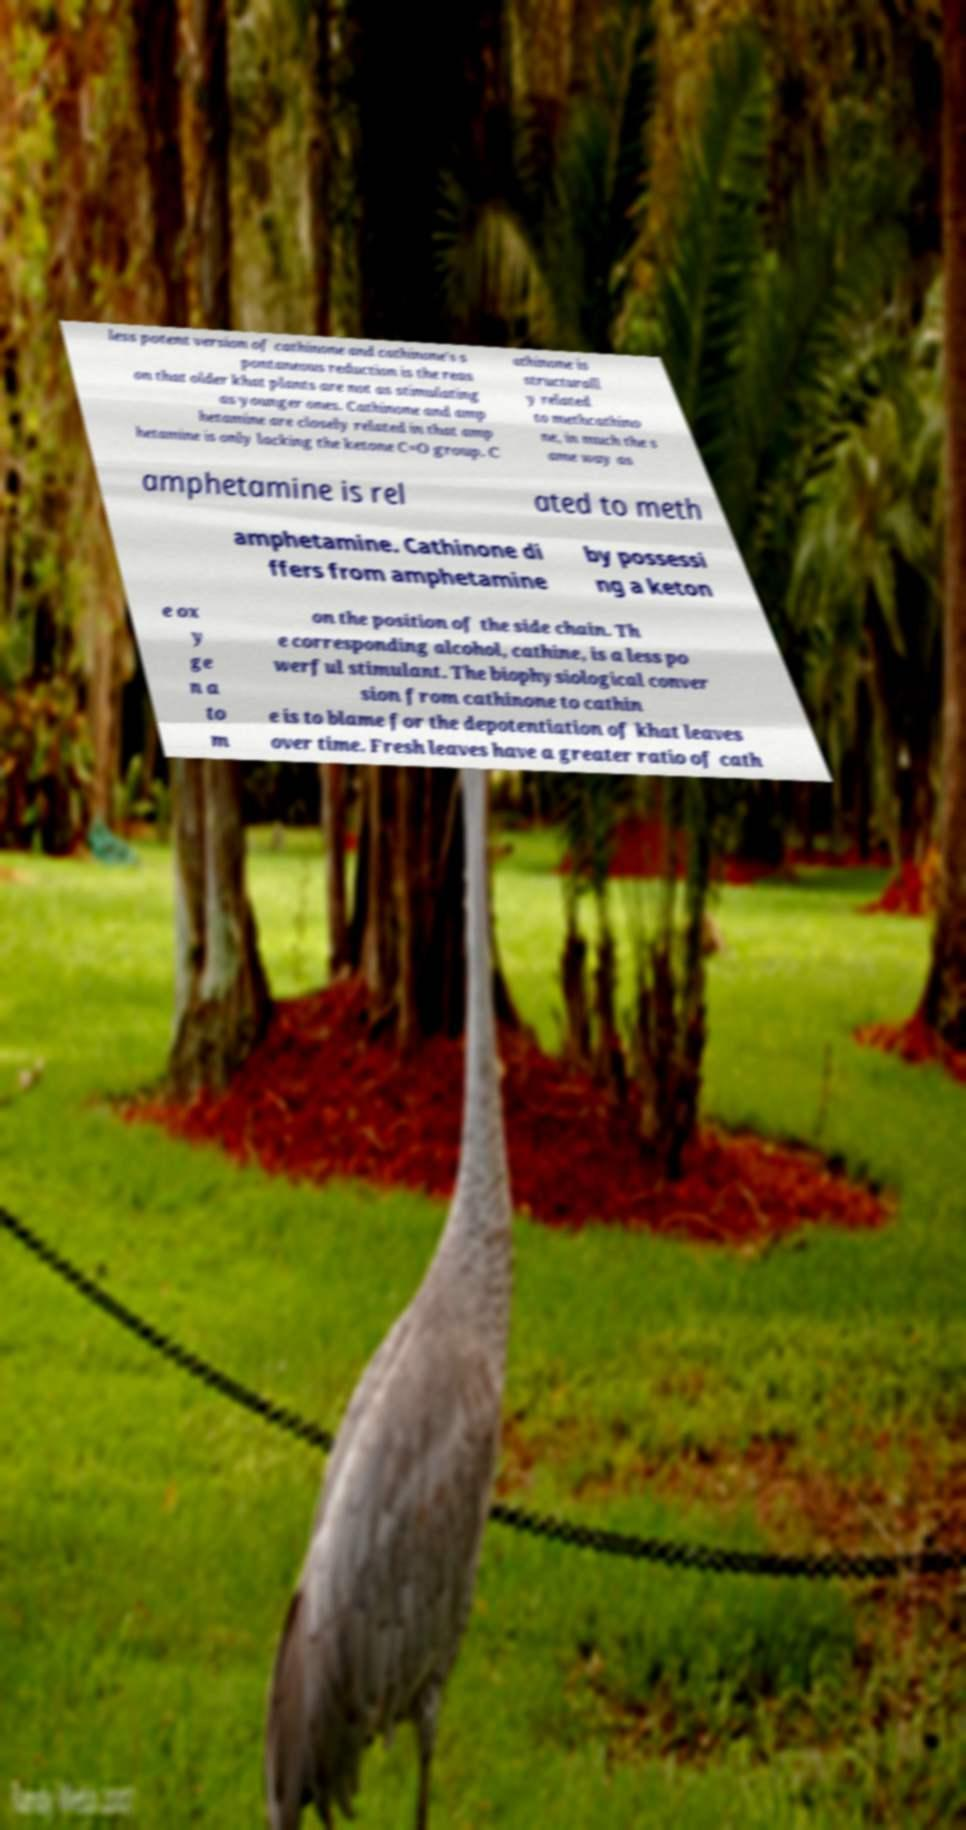Can you read and provide the text displayed in the image?This photo seems to have some interesting text. Can you extract and type it out for me? less potent version of cathinone and cathinone's s pontaneous reduction is the reas on that older khat plants are not as stimulating as younger ones. Cathinone and amp hetamine are closely related in that amp hetamine is only lacking the ketone C=O group. C athinone is structurall y related to methcathino ne, in much the s ame way as amphetamine is rel ated to meth amphetamine. Cathinone di ffers from amphetamine by possessi ng a keton e ox y ge n a to m on the position of the side chain. Th e corresponding alcohol, cathine, is a less po werful stimulant. The biophysiological conver sion from cathinone to cathin e is to blame for the depotentiation of khat leaves over time. Fresh leaves have a greater ratio of cath 